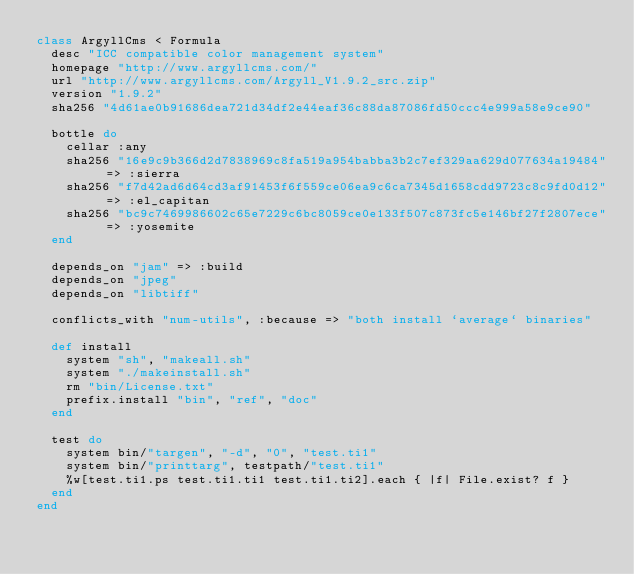<code> <loc_0><loc_0><loc_500><loc_500><_Ruby_>class ArgyllCms < Formula
  desc "ICC compatible color management system"
  homepage "http://www.argyllcms.com/"
  url "http://www.argyllcms.com/Argyll_V1.9.2_src.zip"
  version "1.9.2"
  sha256 "4d61ae0b91686dea721d34df2e44eaf36c88da87086fd50ccc4e999a58e9ce90"

  bottle do
    cellar :any
    sha256 "16e9c9b366d2d7838969c8fa519a954babba3b2c7ef329aa629d077634a19484" => :sierra
    sha256 "f7d42ad6d64cd3af91453f6f559ce06ea9c6ca7345d1658cdd9723c8c9fd0d12" => :el_capitan
    sha256 "bc9c7469986602c65e7229c6bc8059ce0e133f507c873fc5e146bf27f2807ece" => :yosemite
  end

  depends_on "jam" => :build
  depends_on "jpeg"
  depends_on "libtiff"

  conflicts_with "num-utils", :because => "both install `average` binaries"

  def install
    system "sh", "makeall.sh"
    system "./makeinstall.sh"
    rm "bin/License.txt"
    prefix.install "bin", "ref", "doc"
  end

  test do
    system bin/"targen", "-d", "0", "test.ti1"
    system bin/"printtarg", testpath/"test.ti1"
    %w[test.ti1.ps test.ti1.ti1 test.ti1.ti2].each { |f| File.exist? f }
  end
end
</code> 